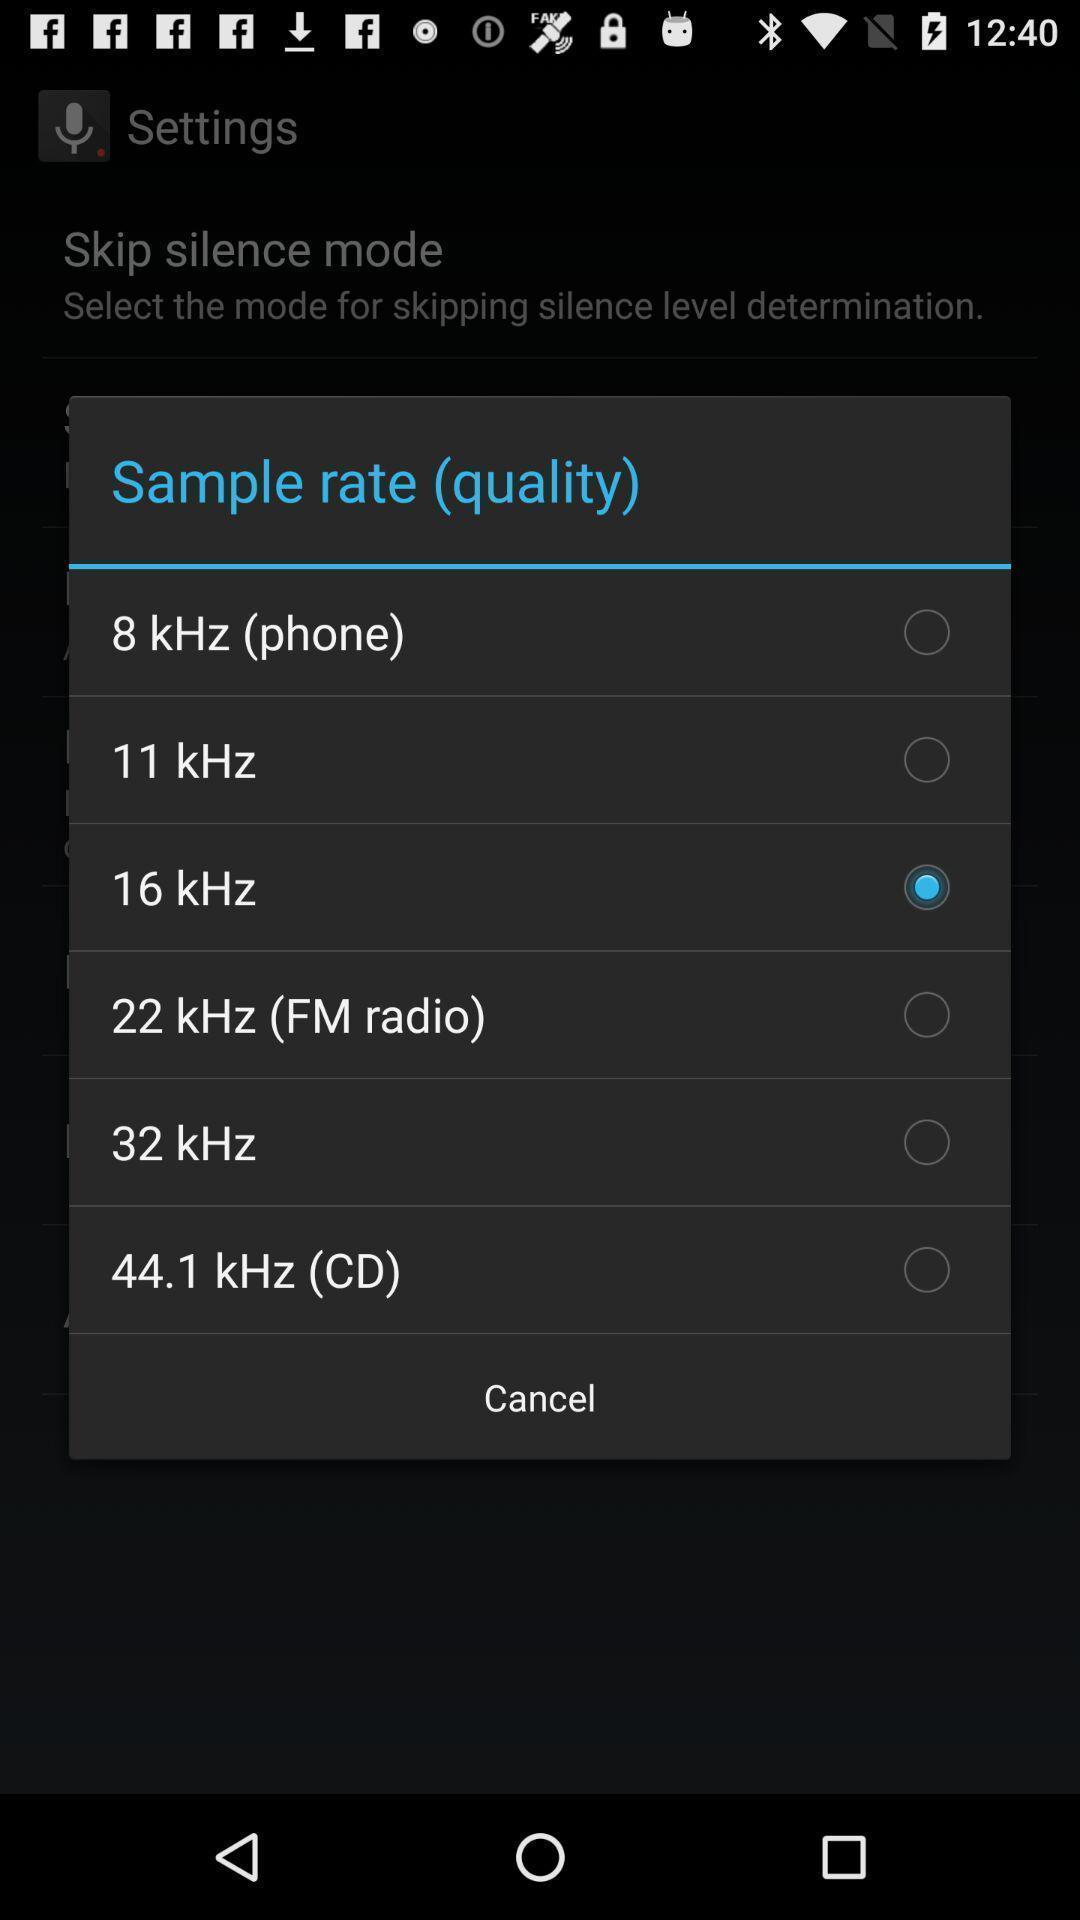Provide a description of this screenshot. Pop-up displaying different qualities to select. 